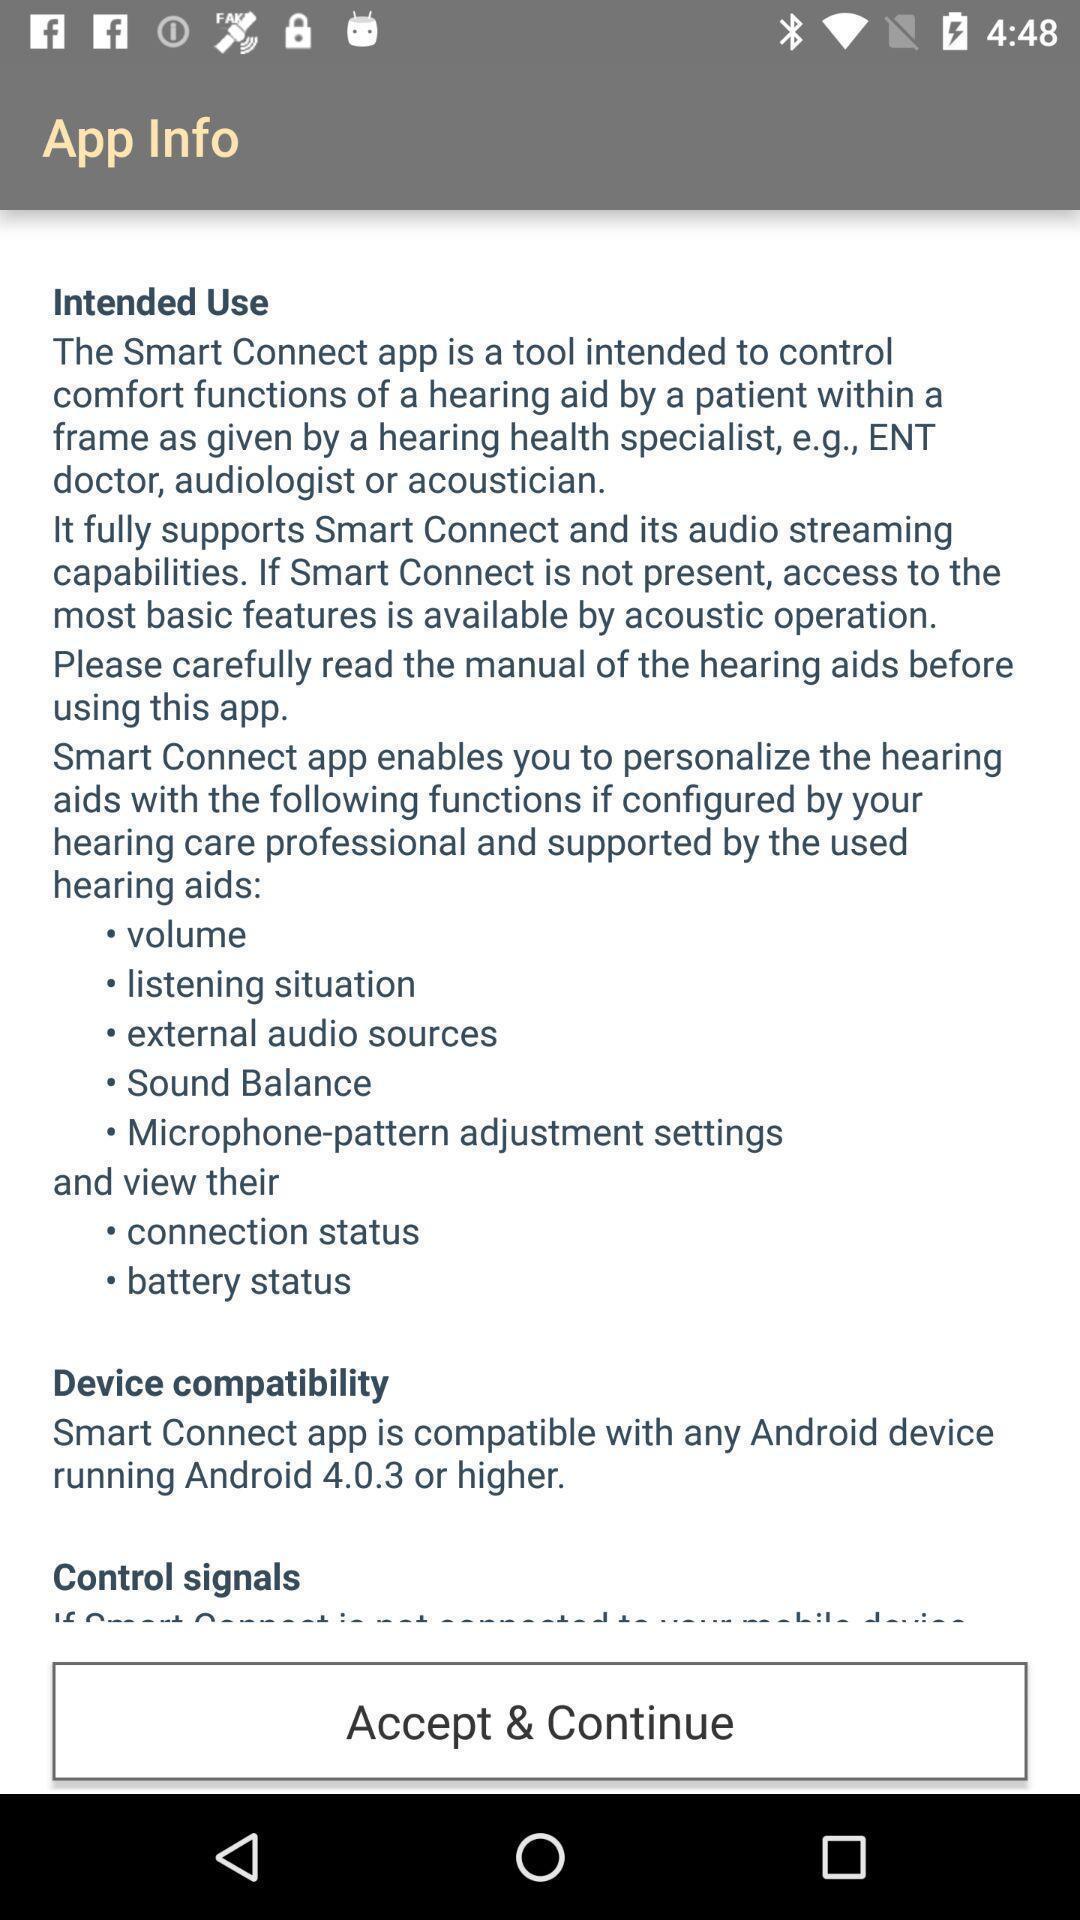What details can you identify in this image? Screen showing the app info for acceptance. 